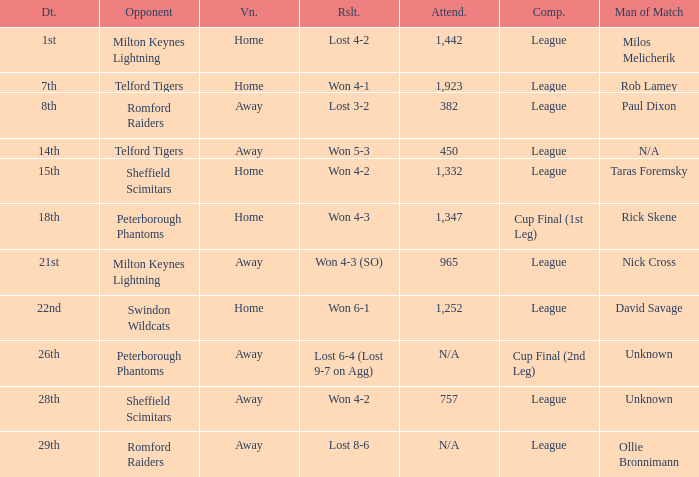What was the result on the 26th? Lost 6-4 (Lost 9-7 on Agg). 